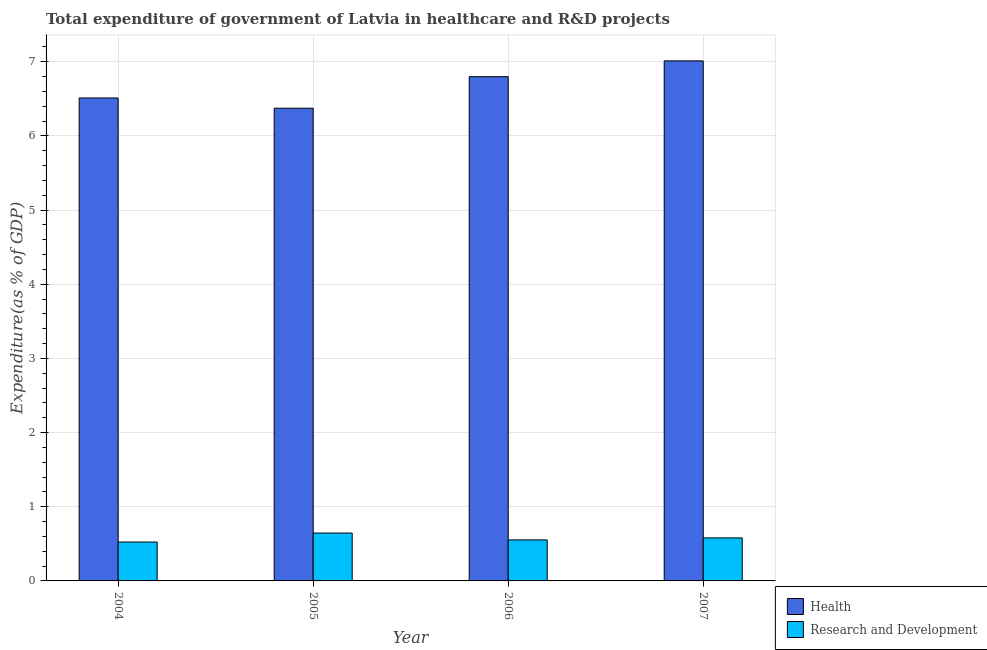Are the number of bars on each tick of the X-axis equal?
Your answer should be compact. Yes. How many bars are there on the 2nd tick from the left?
Offer a very short reply. 2. What is the label of the 1st group of bars from the left?
Your response must be concise. 2004. What is the expenditure in healthcare in 2006?
Make the answer very short. 6.8. Across all years, what is the maximum expenditure in healthcare?
Make the answer very short. 7.01. Across all years, what is the minimum expenditure in healthcare?
Give a very brief answer. 6.37. In which year was the expenditure in healthcare minimum?
Your answer should be compact. 2005. What is the total expenditure in r&d in the graph?
Give a very brief answer. 2.3. What is the difference between the expenditure in healthcare in 2005 and that in 2007?
Provide a succinct answer. -0.64. What is the difference between the expenditure in healthcare in 2006 and the expenditure in r&d in 2007?
Your response must be concise. -0.21. What is the average expenditure in healthcare per year?
Your answer should be compact. 6.67. In how many years, is the expenditure in healthcare greater than 4.6 %?
Offer a terse response. 4. What is the ratio of the expenditure in healthcare in 2006 to that in 2007?
Your response must be concise. 0.97. Is the expenditure in healthcare in 2004 less than that in 2007?
Offer a very short reply. Yes. What is the difference between the highest and the second highest expenditure in r&d?
Offer a very short reply. 0.07. What is the difference between the highest and the lowest expenditure in r&d?
Your answer should be compact. 0.12. In how many years, is the expenditure in healthcare greater than the average expenditure in healthcare taken over all years?
Give a very brief answer. 2. What does the 1st bar from the left in 2005 represents?
Make the answer very short. Health. What does the 2nd bar from the right in 2005 represents?
Keep it short and to the point. Health. Are the values on the major ticks of Y-axis written in scientific E-notation?
Provide a succinct answer. No. Does the graph contain any zero values?
Keep it short and to the point. No. Does the graph contain grids?
Give a very brief answer. Yes. How many legend labels are there?
Provide a succinct answer. 2. What is the title of the graph?
Your response must be concise. Total expenditure of government of Latvia in healthcare and R&D projects. Does "Number of arrivals" appear as one of the legend labels in the graph?
Keep it short and to the point. No. What is the label or title of the X-axis?
Provide a succinct answer. Year. What is the label or title of the Y-axis?
Your response must be concise. Expenditure(as % of GDP). What is the Expenditure(as % of GDP) in Health in 2004?
Offer a very short reply. 6.51. What is the Expenditure(as % of GDP) of Research and Development in 2004?
Ensure brevity in your answer.  0.52. What is the Expenditure(as % of GDP) of Health in 2005?
Ensure brevity in your answer.  6.37. What is the Expenditure(as % of GDP) in Research and Development in 2005?
Your answer should be compact. 0.65. What is the Expenditure(as % of GDP) of Health in 2006?
Keep it short and to the point. 6.8. What is the Expenditure(as % of GDP) in Research and Development in 2006?
Make the answer very short. 0.55. What is the Expenditure(as % of GDP) in Health in 2007?
Your response must be concise. 7.01. What is the Expenditure(as % of GDP) in Research and Development in 2007?
Your response must be concise. 0.58. Across all years, what is the maximum Expenditure(as % of GDP) in Health?
Make the answer very short. 7.01. Across all years, what is the maximum Expenditure(as % of GDP) of Research and Development?
Give a very brief answer. 0.65. Across all years, what is the minimum Expenditure(as % of GDP) of Health?
Offer a very short reply. 6.37. Across all years, what is the minimum Expenditure(as % of GDP) of Research and Development?
Provide a succinct answer. 0.52. What is the total Expenditure(as % of GDP) in Health in the graph?
Offer a terse response. 26.7. What is the total Expenditure(as % of GDP) in Research and Development in the graph?
Your answer should be very brief. 2.3. What is the difference between the Expenditure(as % of GDP) in Health in 2004 and that in 2005?
Provide a short and direct response. 0.14. What is the difference between the Expenditure(as % of GDP) in Research and Development in 2004 and that in 2005?
Ensure brevity in your answer.  -0.12. What is the difference between the Expenditure(as % of GDP) in Health in 2004 and that in 2006?
Your answer should be very brief. -0.29. What is the difference between the Expenditure(as % of GDP) of Research and Development in 2004 and that in 2006?
Give a very brief answer. -0.03. What is the difference between the Expenditure(as % of GDP) of Health in 2004 and that in 2007?
Your answer should be very brief. -0.5. What is the difference between the Expenditure(as % of GDP) in Research and Development in 2004 and that in 2007?
Ensure brevity in your answer.  -0.06. What is the difference between the Expenditure(as % of GDP) in Health in 2005 and that in 2006?
Give a very brief answer. -0.42. What is the difference between the Expenditure(as % of GDP) of Research and Development in 2005 and that in 2006?
Make the answer very short. 0.09. What is the difference between the Expenditure(as % of GDP) of Health in 2005 and that in 2007?
Ensure brevity in your answer.  -0.64. What is the difference between the Expenditure(as % of GDP) in Research and Development in 2005 and that in 2007?
Your answer should be compact. 0.07. What is the difference between the Expenditure(as % of GDP) in Health in 2006 and that in 2007?
Provide a short and direct response. -0.21. What is the difference between the Expenditure(as % of GDP) of Research and Development in 2006 and that in 2007?
Provide a short and direct response. -0.03. What is the difference between the Expenditure(as % of GDP) of Health in 2004 and the Expenditure(as % of GDP) of Research and Development in 2005?
Your answer should be very brief. 5.87. What is the difference between the Expenditure(as % of GDP) of Health in 2004 and the Expenditure(as % of GDP) of Research and Development in 2006?
Make the answer very short. 5.96. What is the difference between the Expenditure(as % of GDP) of Health in 2004 and the Expenditure(as % of GDP) of Research and Development in 2007?
Give a very brief answer. 5.93. What is the difference between the Expenditure(as % of GDP) in Health in 2005 and the Expenditure(as % of GDP) in Research and Development in 2006?
Keep it short and to the point. 5.82. What is the difference between the Expenditure(as % of GDP) in Health in 2005 and the Expenditure(as % of GDP) in Research and Development in 2007?
Offer a terse response. 5.79. What is the difference between the Expenditure(as % of GDP) of Health in 2006 and the Expenditure(as % of GDP) of Research and Development in 2007?
Provide a short and direct response. 6.22. What is the average Expenditure(as % of GDP) of Health per year?
Give a very brief answer. 6.67. What is the average Expenditure(as % of GDP) in Research and Development per year?
Your answer should be very brief. 0.58. In the year 2004, what is the difference between the Expenditure(as % of GDP) of Health and Expenditure(as % of GDP) of Research and Development?
Provide a succinct answer. 5.99. In the year 2005, what is the difference between the Expenditure(as % of GDP) of Health and Expenditure(as % of GDP) of Research and Development?
Make the answer very short. 5.73. In the year 2006, what is the difference between the Expenditure(as % of GDP) in Health and Expenditure(as % of GDP) in Research and Development?
Make the answer very short. 6.25. In the year 2007, what is the difference between the Expenditure(as % of GDP) in Health and Expenditure(as % of GDP) in Research and Development?
Ensure brevity in your answer.  6.43. What is the ratio of the Expenditure(as % of GDP) of Health in 2004 to that in 2005?
Provide a short and direct response. 1.02. What is the ratio of the Expenditure(as % of GDP) in Research and Development in 2004 to that in 2005?
Provide a short and direct response. 0.81. What is the ratio of the Expenditure(as % of GDP) in Health in 2004 to that in 2006?
Offer a terse response. 0.96. What is the ratio of the Expenditure(as % of GDP) in Research and Development in 2004 to that in 2006?
Ensure brevity in your answer.  0.95. What is the ratio of the Expenditure(as % of GDP) in Health in 2004 to that in 2007?
Your answer should be compact. 0.93. What is the ratio of the Expenditure(as % of GDP) of Research and Development in 2004 to that in 2007?
Your answer should be very brief. 0.9. What is the ratio of the Expenditure(as % of GDP) in Research and Development in 2005 to that in 2006?
Your response must be concise. 1.17. What is the ratio of the Expenditure(as % of GDP) in Health in 2005 to that in 2007?
Give a very brief answer. 0.91. What is the ratio of the Expenditure(as % of GDP) of Research and Development in 2005 to that in 2007?
Provide a succinct answer. 1.11. What is the ratio of the Expenditure(as % of GDP) of Health in 2006 to that in 2007?
Provide a succinct answer. 0.97. What is the ratio of the Expenditure(as % of GDP) of Research and Development in 2006 to that in 2007?
Your answer should be very brief. 0.95. What is the difference between the highest and the second highest Expenditure(as % of GDP) of Health?
Provide a succinct answer. 0.21. What is the difference between the highest and the second highest Expenditure(as % of GDP) in Research and Development?
Give a very brief answer. 0.07. What is the difference between the highest and the lowest Expenditure(as % of GDP) in Health?
Keep it short and to the point. 0.64. What is the difference between the highest and the lowest Expenditure(as % of GDP) in Research and Development?
Make the answer very short. 0.12. 